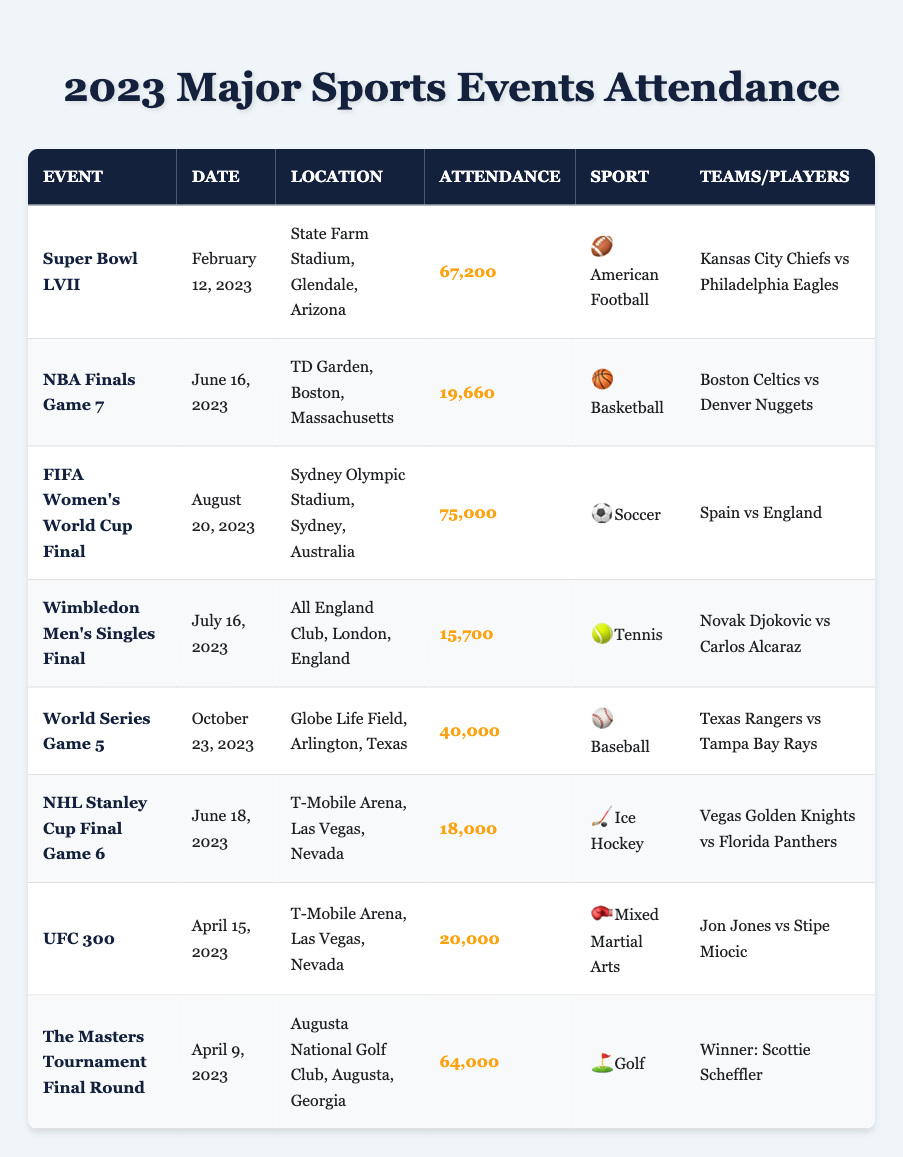What is the attendance for the Super Bowl LVII? The table shows that the attendance for the Super Bowl LVII, held on February 12, 2023, at State Farm Stadium, Glendale, Arizona, was listed as 67,200.
Answer: 67,200 Which sport had the highest attendance in 2023? The highest attendance was at the FIFA Women's World Cup Final, which had 75,000 attendees. This can be found by comparing the attendance figures from all events listed.
Answer: Soccer How many people attended the NHL Stanley Cup Final Game 6? According to the data in the table, the NHL Stanley Cup Final Game 6, which took place on June 18, 2023, had an attendance of 18,000.
Answer: 18,000 What is the average attendance of the events listed in the table? To find the average attendance, we first need to sum the attendance numbers: 67,200 + 19,660 + 75,000 + 15,700 + 40,000 + 18,000 + 20,000 + 64,000 = 319,560. Then, we divide that sum by the number of events, which is 8: 319,560 / 8 = 39,945.
Answer: 39,945 Was the attendance for the Wimbledon Men's Singles Final greater than 20,000? The attendance for the Wimbledon Men's Singles Final is recorded as 15,700 according to the table, which indicates it was less than 20,000. Thus, the statement is false.
Answer: No Which two teams faced each other in the NBA Finals Game 7? The table specifies that the teams that played in the NBA Finals Game 7 on June 16, 2023, were the Boston Celtics and the Denver Nuggets.
Answer: Boston Celtics vs Denver Nuggets How many more attendees were present at the FIFA Women's World Cup Final compared to the Wimbledon Men's Singles Final? The attendance for the FIFA Women's World Cup Final was 75,000, and for the Wimbledon Men's Singles Final, it was 15,700. The difference is calculated as 75,000 - 15,700 = 59,300.
Answer: 59,300 Did the UFC 300 event take place before the FIFA Women's World Cup Final? The UFC 300 event occurred on April 15, 2023, while the FIFA Women's World Cup Final took place on August 20, 2023. Thus, this statement is true.
Answer: Yes What location hosted the World Series Game 5? The World Series Game 5 was held at Globe Life Field, Arlington, Texas, as noted in the table under the corresponding event details.
Answer: Globe Life Field, Arlington, Texas 